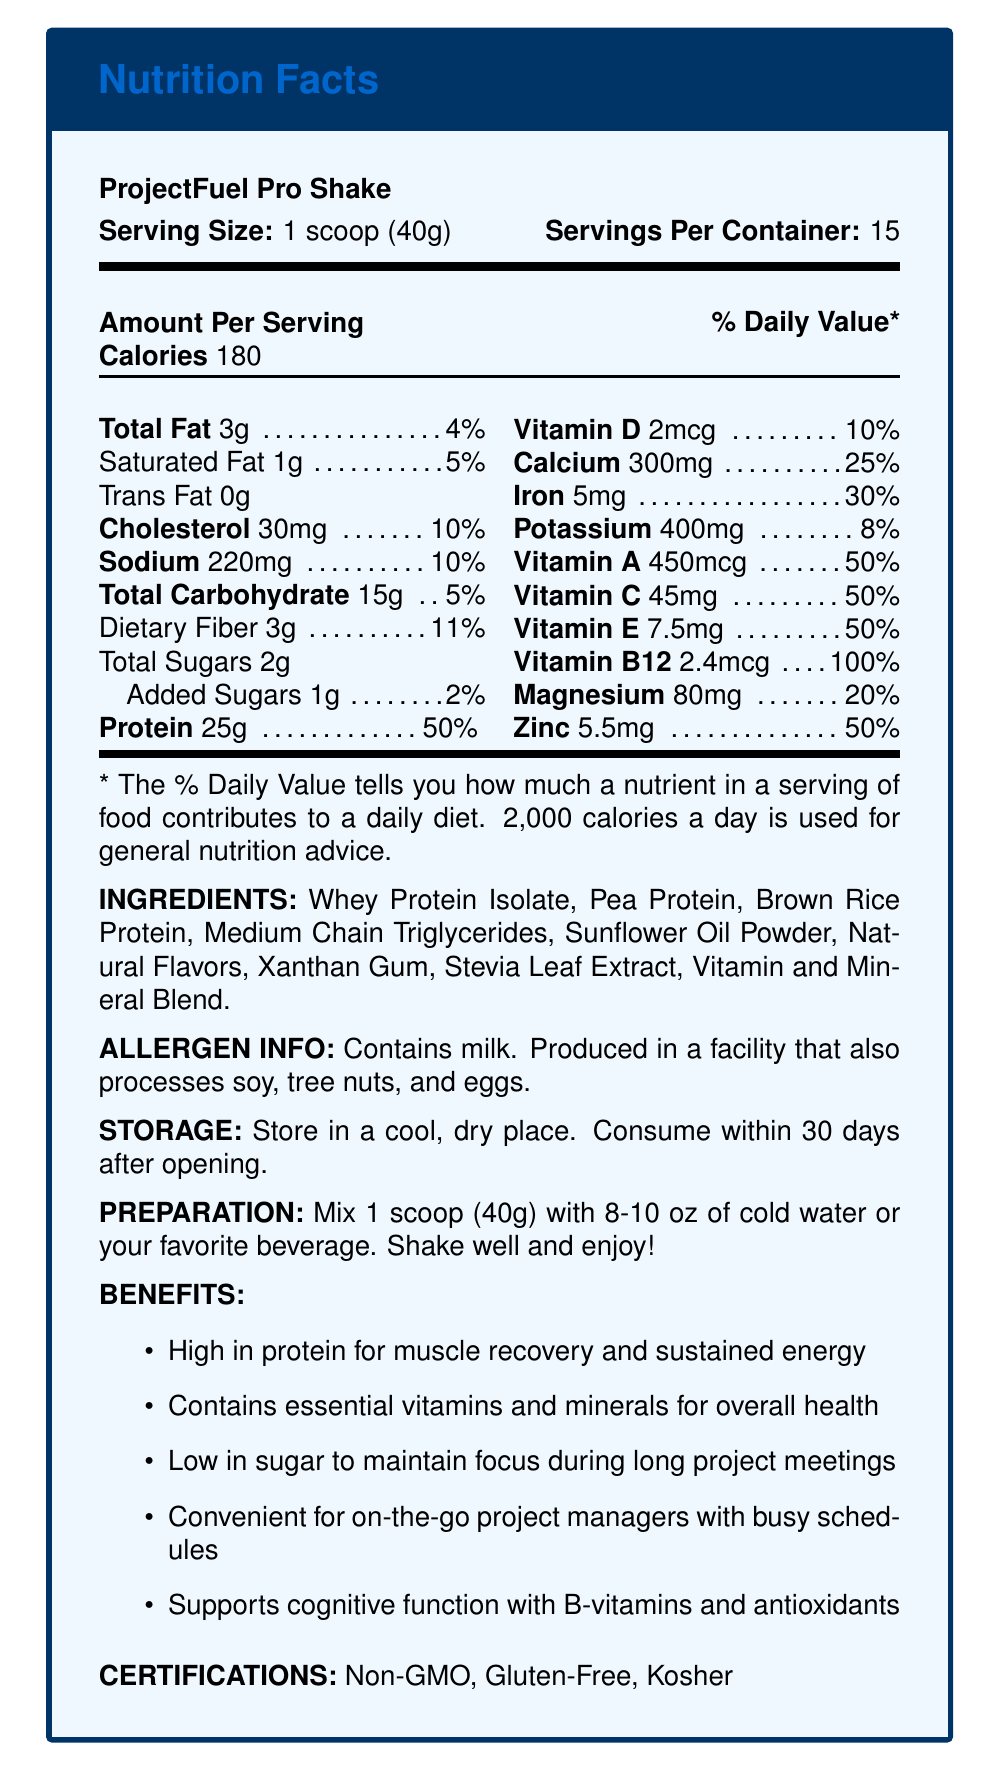what is the serving size of ProjectFuel Pro Shake? The serving size is specified as "1 scoop (40g)" in the document.
Answer: 1 scoop (40g) how many servings are there per container? The document states that there are 15 servings per container.
Answer: 15 how many grams of protein are in one serving? The document details that one serving contains 25g of protein.
Answer: 25g what is the percentage of daily value for vitamin B12 in one serving? The daily value percentage for vitamin B12 is shown as 100% in one serving.
Answer: 100% name three main protein sources in the ingredients list. The ingredients list includes Whey Protein Isolate, Pea Protein, and Brown Rice Protein as the main protein sources.
Answer: Whey Protein Isolate, Pea Protein, Brown Rice Protein which vitamin has the highest daily value percentage? A. Vitamin A B. Vitamin C C. Vitamin B12 D. Vitamin D Vitamin B12 has the highest daily value percentage at 100% compared to other vitamins.
Answer: C. Vitamin B12 how many calories does one serving of ProjectFuel Pro Shake contain? The document indicates that one serving contains 180 calories.
Answer: 180 which of the following benefits is *not* listed in the document? A. Supports immune health B. High in protein for muscle recovery and sustained energy C. Low in sugar to maintain focus during long project meetings D. Contains essential vitamins and minerals for overall health The document lists benefits related to high protein, low sugar, essential vitamins, and minerals, but does not mention immune health.
Answer: A. Supports immune health is the product certified non-GMO? The document mentions that the product is certified as Non-GMO.
Answer: Yes can you determine the exact ingredients of the "Vitamin and Mineral Blend"? The document states "Vitamin and Mineral Blend" but does not provide the exact ingredients of this blend.
Answer: Not enough information summarize the main benefits and features of ProjectFuel Pro Shake. The document highlights the protein content, vitamins, and minerals, convenience for busy schedules, and low sugar as key benefits. It also lists product certifications.
Answer: ProjectFuel Pro Shake is a high-protein meal replacement shake designed for on-the-go project managers, offering muscle recovery, sustained energy, and essential vitamins and minerals. It's low in sugar to maintain focus during long meetings and supports cognitive function with B-vitamins and antioxidants. The product is convenient, Non-GMO, Gluten-Free, and Kosher. 